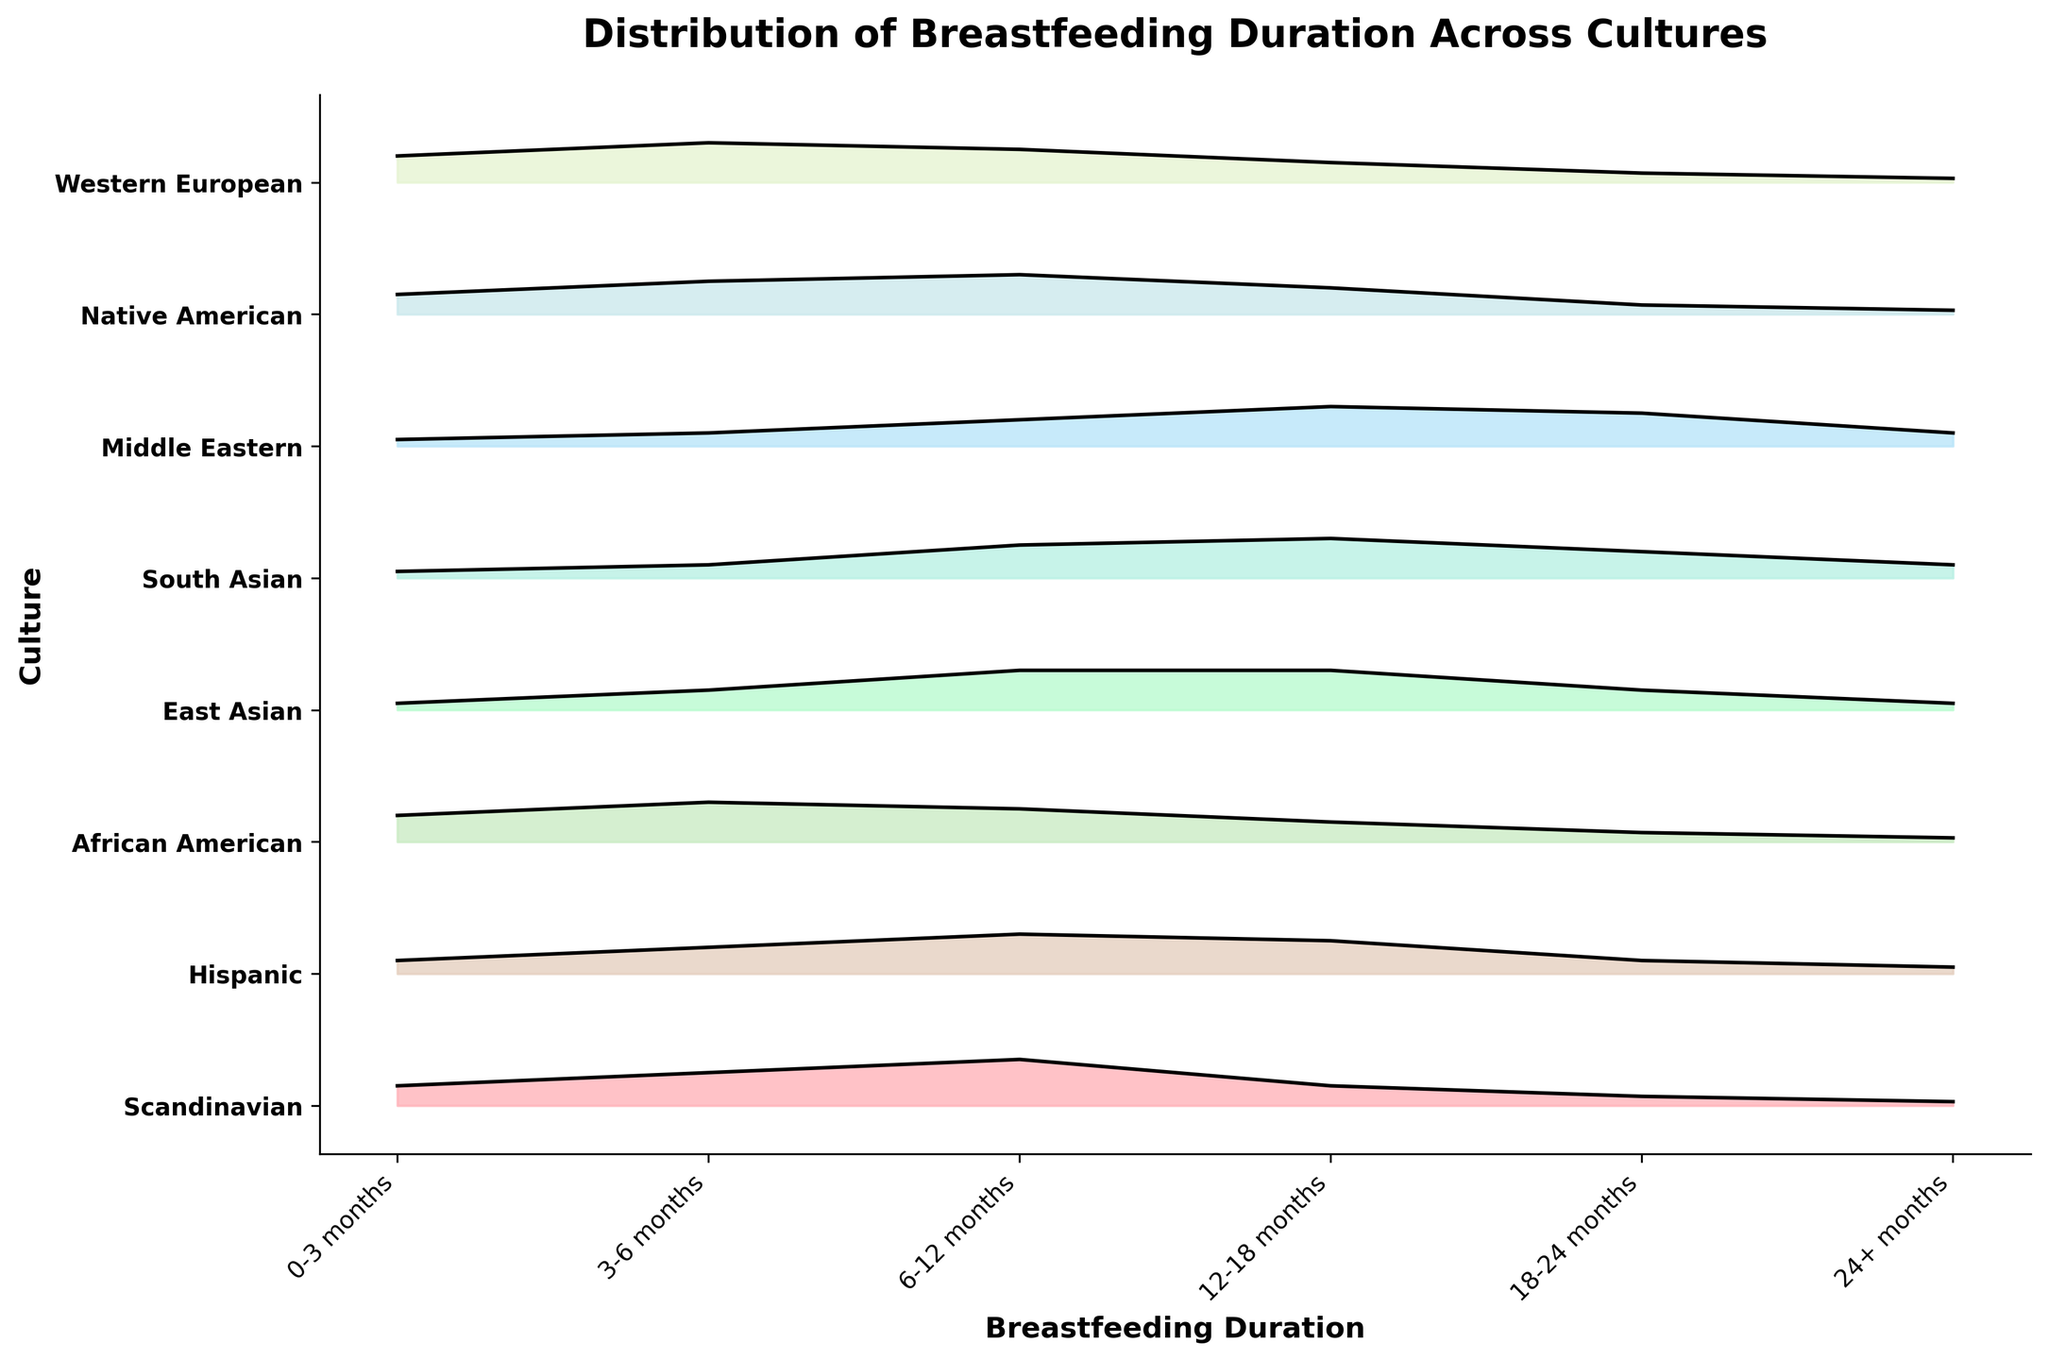What is the title of the figure? The title of a figure is usually prominently displayed at the top in large bold text. For this ridgeline plot, the title is: "Distribution of Breastfeeding Duration Across Cultures."
Answer: Distribution of Breastfeeding Duration Across Cultures Which culture has the highest percentage for breastfeeding duration of 3-6 months? The figure shows the different cultures and their corresponding breastfeeding durations. By locating the duration '3-6 months' on the x-axis and checking the data for each culture, we can see that African American and Western European cultures both peak at 30% for this duration.
Answer: African American and Western European Which cultures have a higher percentage of breastfeeding duration between 12 and 18 months compared to the 0-3 months duration? To determine this, we need to compare the height of the plot bars for 12-18 months with 0-3 months for each culture. Cultures that fulfill this criteria in the figure are East Asian, South Asian, Middle Eastern, and Hispanic.
Answer: East Asian, South Asian, Middle Eastern, Hispanic What is the pattern for breastfeeding duration of 24+ months across different cultures? Observing the rightmost section of the plot for each culture, East Asian, South Asian, and Middle Eastern cultures show higher proportions, indicating longer breastfeeding durations compared to the others.
Answer: East Asian, South Asian, Middle Eastern Which culture shows the lowest percentage for breastfeeding duration of 24+ months? The figure indicates the bars for each duration and culture. By examining the rightmost plot marks for 24+ months, the Scandinavian culture has the lowest peak around 3%.
Answer: Scandinavian How does the percentage of 0-3 months breastfeeding duration in the Scandinavian culture compare to the Hispanic culture? Look at the heights of the plots for the '0-3 months' duration for both Scandinavian and Hispanic cultures. The Scandinavian culture has a plot height of 15% while the Hispanic culture has 10%.
Answer: Scandinavian is higher Which culture has a more even distribution of breastfeeding durations across all categories? An even distribution means that the segments for each duration category are roughly equal. The Hispanic culture shows relatively uniform distribution across all durations compared to the other cultures.
Answer: Hispanic In which culture do the highest number of categories peak at 30%? By counting the peaks at 30% across the cultures, we see that East Asian, South Asian, and Middle Eastern cultures each hit 30% three times in different durations.
Answer: East Asian, South Asian, Middle Eastern What breastfeeding duration has the smallest variability across cultures? Analyzing the plot, the variability is smallest for the '0-3 months' duration as the range across all cultures is between 5% and 20%, a narrower spread compared to other durations.
Answer: 0-3 months 